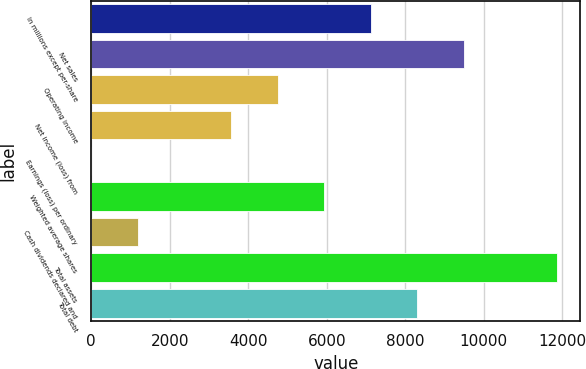Convert chart to OTSL. <chart><loc_0><loc_0><loc_500><loc_500><bar_chart><fcel>In millions except per-share<fcel>Net sales<fcel>Operating income<fcel>Net income (loss) from<fcel>Earnings (loss) per ordinary<fcel>Weighted average shares<fcel>Cash dividends declared and<fcel>Total assets<fcel>Total debt<nl><fcel>7122.41<fcel>9496.49<fcel>4748.33<fcel>3561.29<fcel>0.17<fcel>5935.37<fcel>1187.21<fcel>11870.6<fcel>8309.45<nl></chart> 